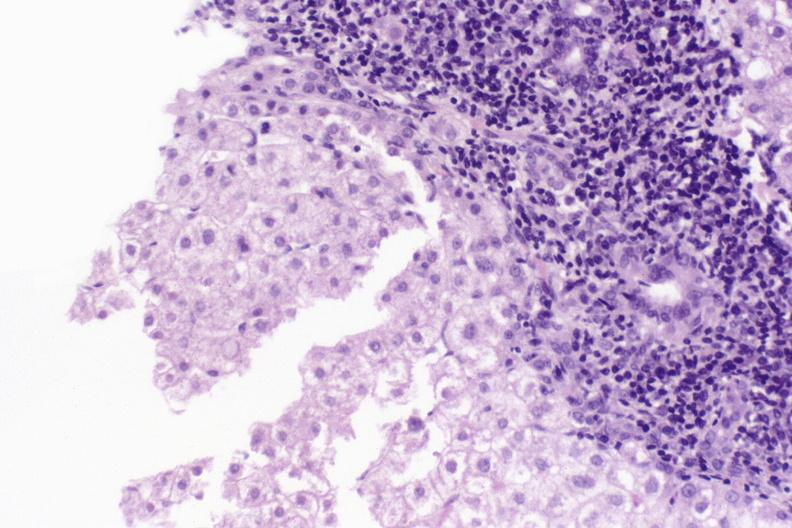does sickle cell disease show primary biliary cirrhosis?
Answer the question using a single word or phrase. No 